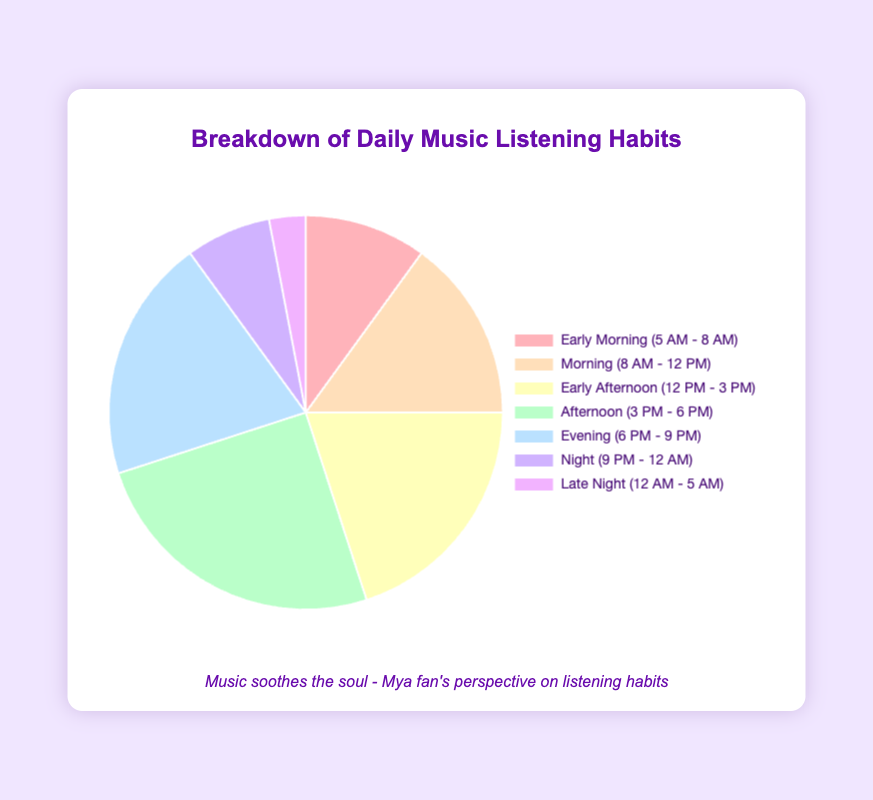Which time of day has the highest percentage of music listening? The highest percentage of music listening is represented by the largest segment of the pie chart.
Answer: Afternoon (3 PM - 6 PM) What is the combined percentage of music listening in the morning and evening periods? Add the percentages for Morning (15%) and Evening (20%).
Answer: 35% Which period has the least amount of music listening? Identify the smallest segment of the pie chart.
Answer: Late Night (12 AM - 5 AM) How does the percentage of music listening in Early Afternoon compare to that in the Night period? Compare the percentages of Early Afternoon (20%) and Night (7%).
Answer: Early Afternoon is higher What is the total percentage of music listened to from 12 PM to 6 PM? Sum the percentages for Early Afternoon (20%) and Afternoon (25%).
Answer: 45% Between Evening and Night, which period sees more music listening? Compare the percentages for Evening (20%) and Night (7%).
Answer: Evening Which segment is larger: Early Morning or Late Night? Compare the percentages for Early Morning (10%) and Late Night (3%).
Answer: Early Morning By how much does the percentage of music listening in the Afternoon exceed that in the Early Morning? Subtract the percentage for Early Morning (10%) from that for Afternoon (25%).
Answer: 15% What is the average percentage of music listening across all periods? Sum all percentages (10 + 15 + 20 + 25 + 20 + 7 + 3 = 100) and divide by the number of periods (7).
Answer: 14.3% Which color segment represents the Night period, and how can it be identified visually? Observe the chart and identify the color associated with the label "Night (9 PM - 12 AM)".
Answer: A light purple segment 